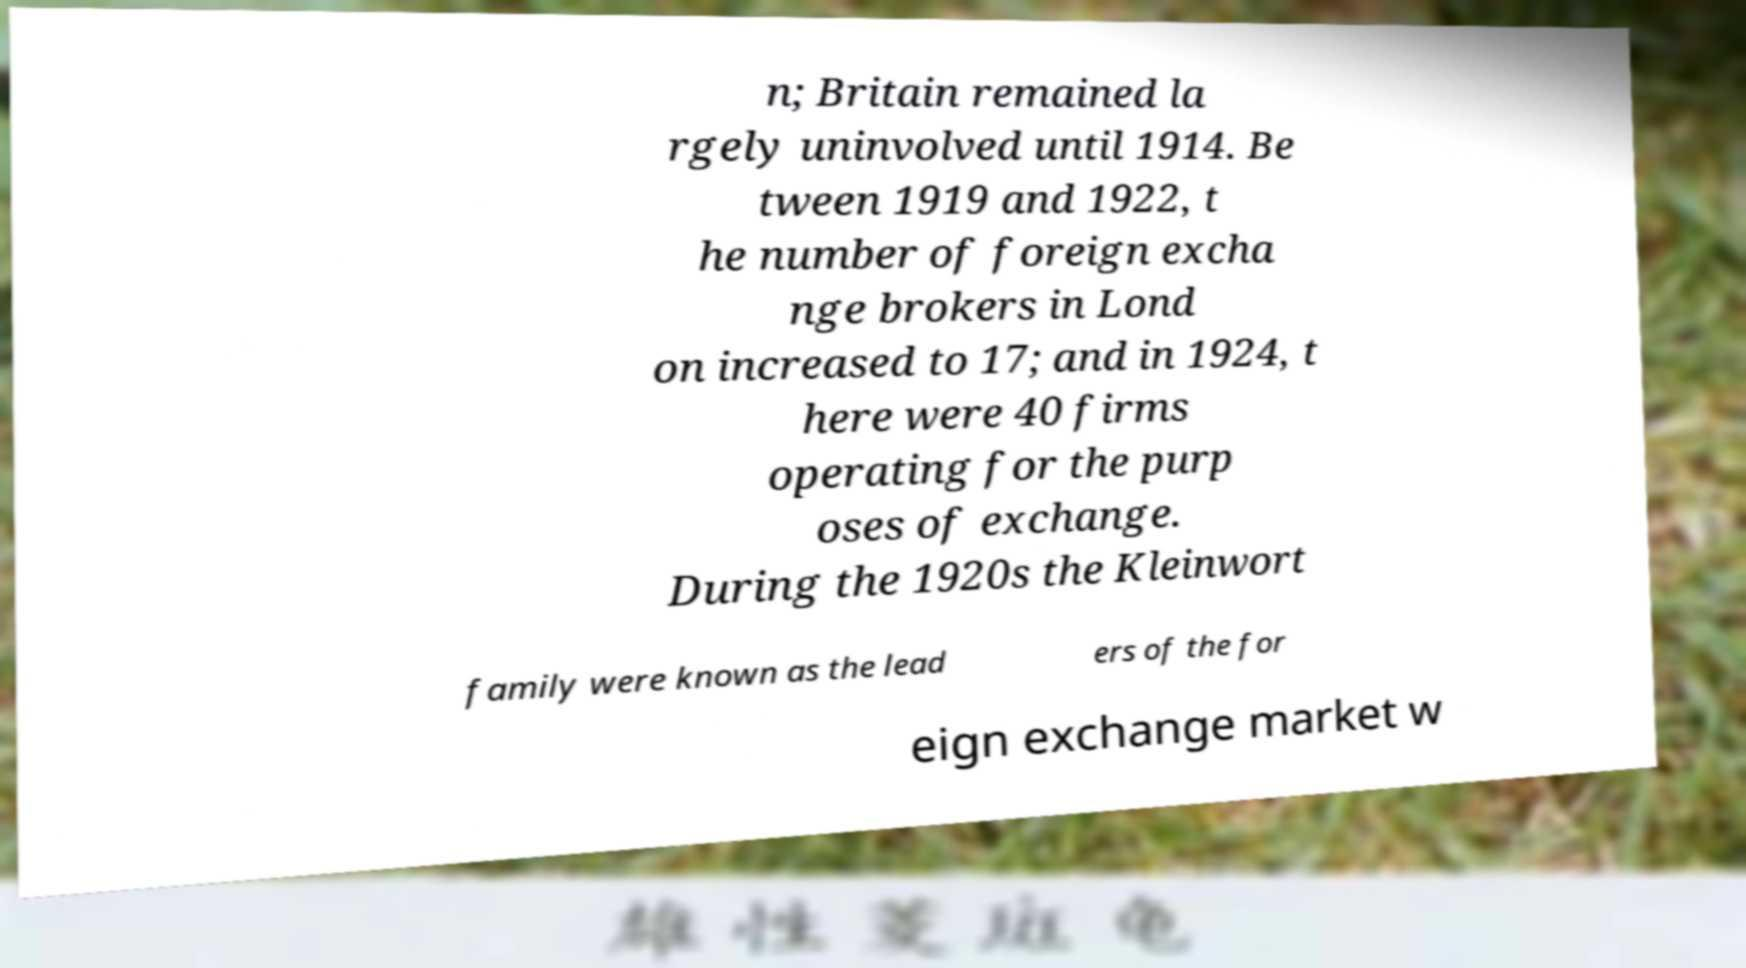I need the written content from this picture converted into text. Can you do that? n; Britain remained la rgely uninvolved until 1914. Be tween 1919 and 1922, t he number of foreign excha nge brokers in Lond on increased to 17; and in 1924, t here were 40 firms operating for the purp oses of exchange. During the 1920s the Kleinwort family were known as the lead ers of the for eign exchange market w 